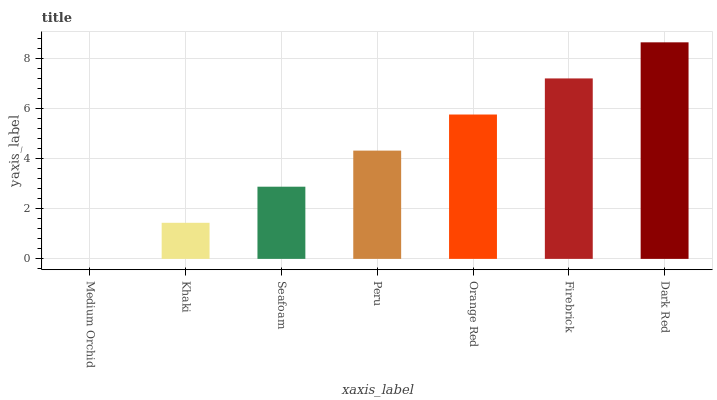Is Medium Orchid the minimum?
Answer yes or no. Yes. Is Dark Red the maximum?
Answer yes or no. Yes. Is Khaki the minimum?
Answer yes or no. No. Is Khaki the maximum?
Answer yes or no. No. Is Khaki greater than Medium Orchid?
Answer yes or no. Yes. Is Medium Orchid less than Khaki?
Answer yes or no. Yes. Is Medium Orchid greater than Khaki?
Answer yes or no. No. Is Khaki less than Medium Orchid?
Answer yes or no. No. Is Peru the high median?
Answer yes or no. Yes. Is Peru the low median?
Answer yes or no. Yes. Is Seafoam the high median?
Answer yes or no. No. Is Medium Orchid the low median?
Answer yes or no. No. 